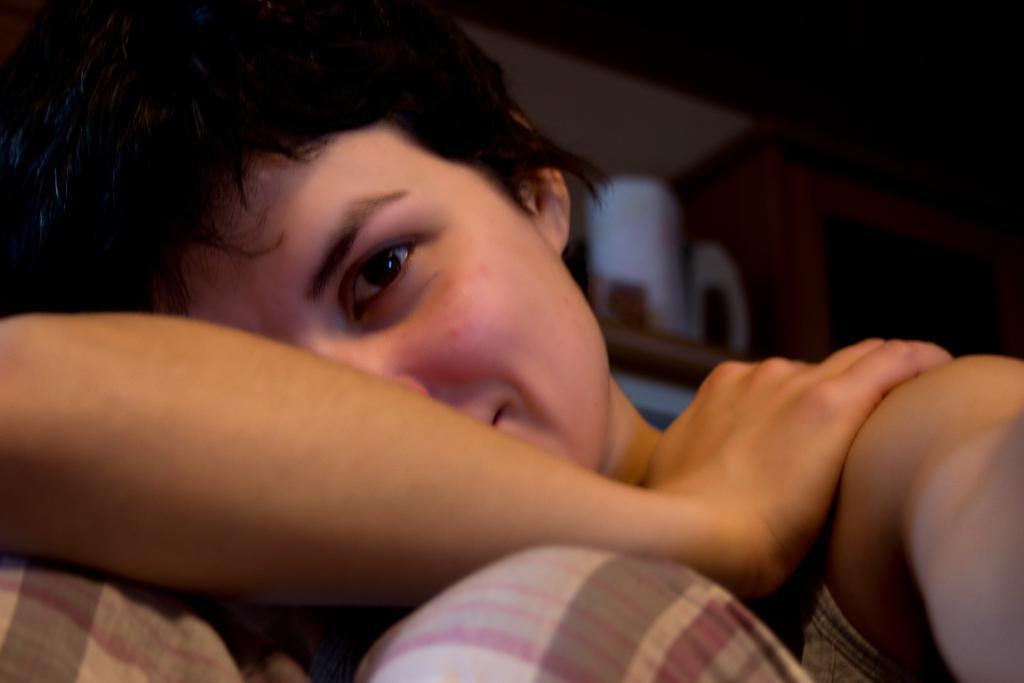How would you summarize this image in a sentence or two? In the center of the image, we can see a person and in the background, there are some objects. 